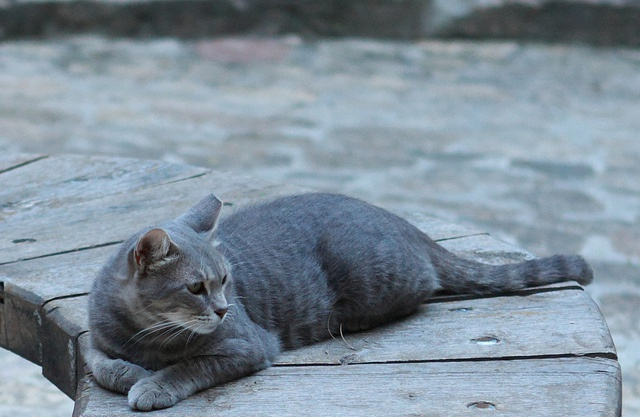Describe the objects in this image and their specific colors. I can see bench in gray, darkgray, lightblue, and black tones and cat in gray and black tones in this image. 